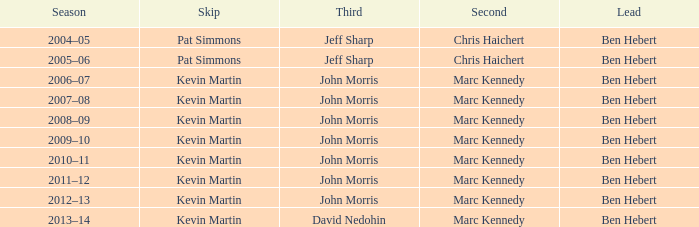Help me parse the entirety of this table. {'header': ['Season', 'Skip', 'Third', 'Second', 'Lead'], 'rows': [['2004–05', 'Pat Simmons', 'Jeff Sharp', 'Chris Haichert', 'Ben Hebert'], ['2005–06', 'Pat Simmons', 'Jeff Sharp', 'Chris Haichert', 'Ben Hebert'], ['2006–07', 'Kevin Martin', 'John Morris', 'Marc Kennedy', 'Ben Hebert'], ['2007–08', 'Kevin Martin', 'John Morris', 'Marc Kennedy', 'Ben Hebert'], ['2008–09', 'Kevin Martin', 'John Morris', 'Marc Kennedy', 'Ben Hebert'], ['2009–10', 'Kevin Martin', 'John Morris', 'Marc Kennedy', 'Ben Hebert'], ['2010–11', 'Kevin Martin', 'John Morris', 'Marc Kennedy', 'Ben Hebert'], ['2011–12', 'Kevin Martin', 'John Morris', 'Marc Kennedy', 'Ben Hebert'], ['2012–13', 'Kevin Martin', 'John Morris', 'Marc Kennedy', 'Ben Hebert'], ['2013–14', 'Kevin Martin', 'David Nedohin', 'Marc Kennedy', 'Ben Hebert']]} Who is the third david nedohin's lead? Ben Hebert. 